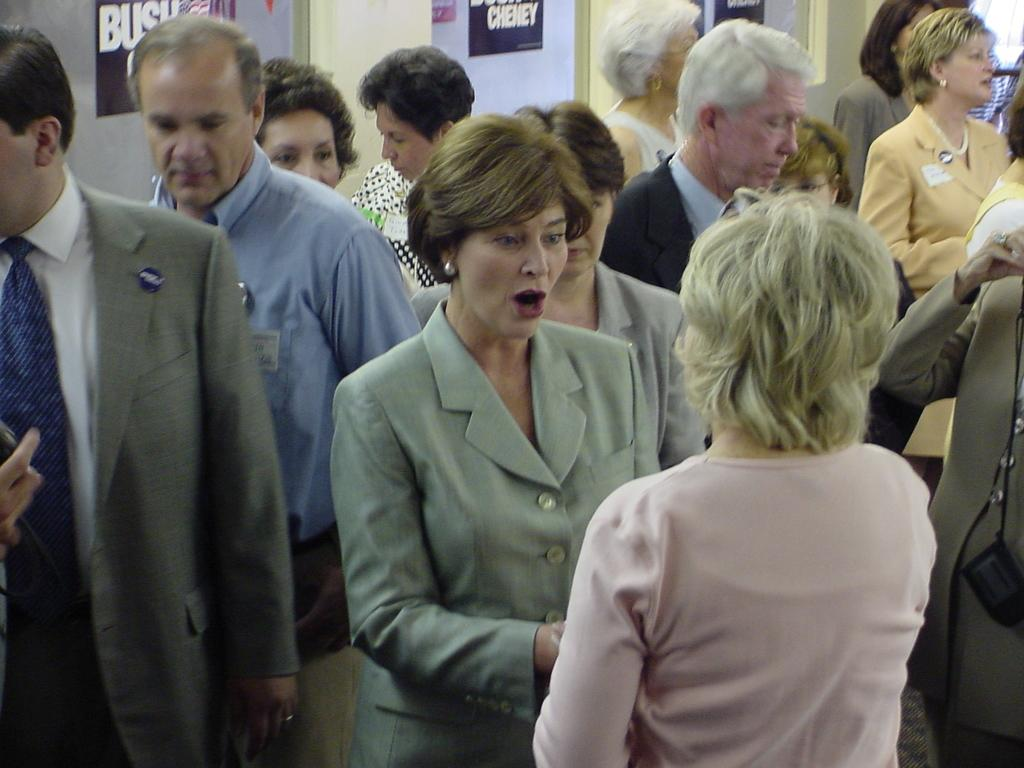What types of people are present in the image? There are men and women in the image. What are the men and women doing in the image? The men and women are standing. What can be seen in the background of the image? There are posters in the background of the image. What type of surprise can be seen in the image? There is no surprise present in the image; it features men and women standing with posters in the background. 